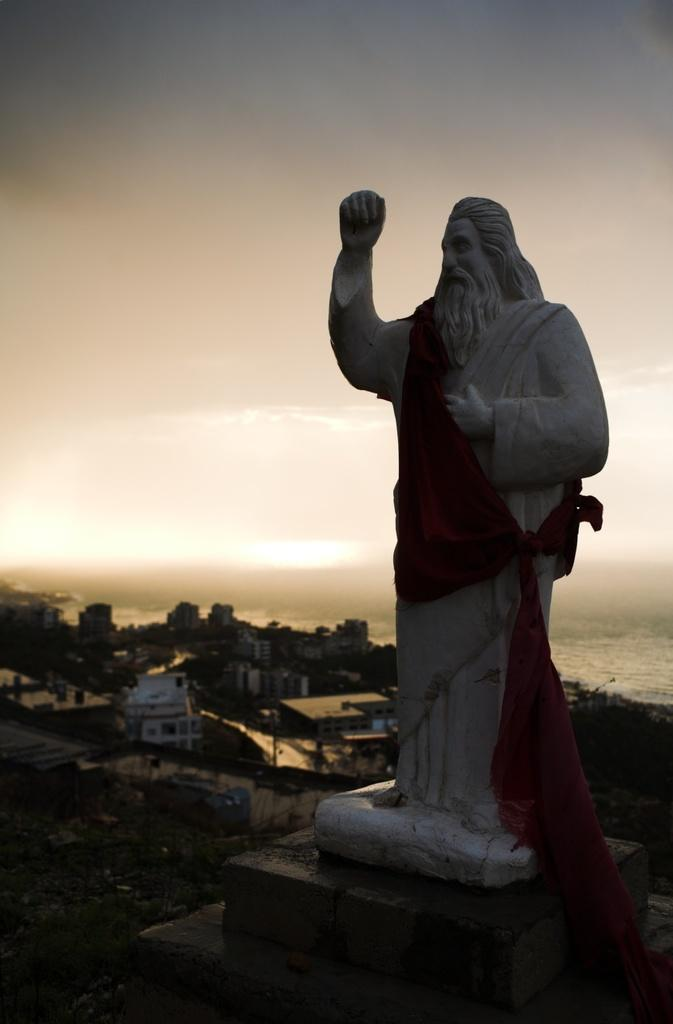What is the main subject in the middle of the image? There is a statue in the middle of the image. What can be seen in the background of the image? There are houses, buildings, and trees in the background of the image. What is visible at the top of the image? The sky is visible at the top of the image. Where is the game board located in the image? There is no game board present in the image. What type of mailbox can be seen near the statue in the image? There is no mailbox present in the image. 